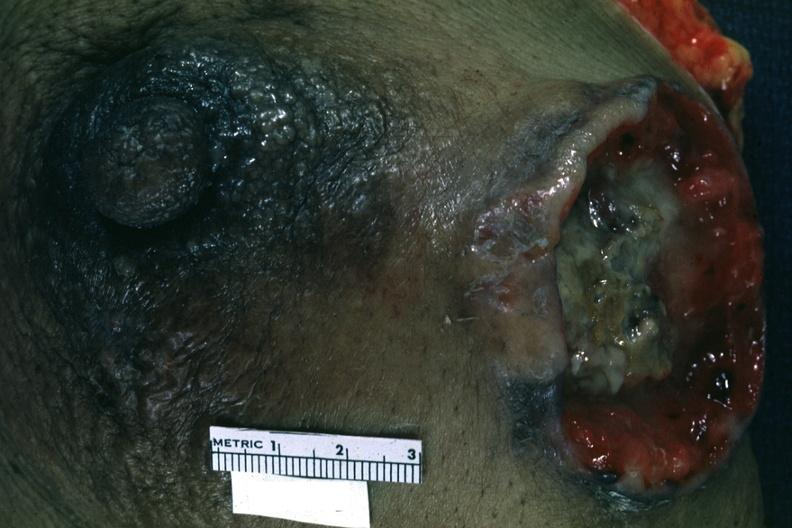does side show close-up excised breast with large ulcerating carcinoma?
Answer the question using a single word or phrase. No 